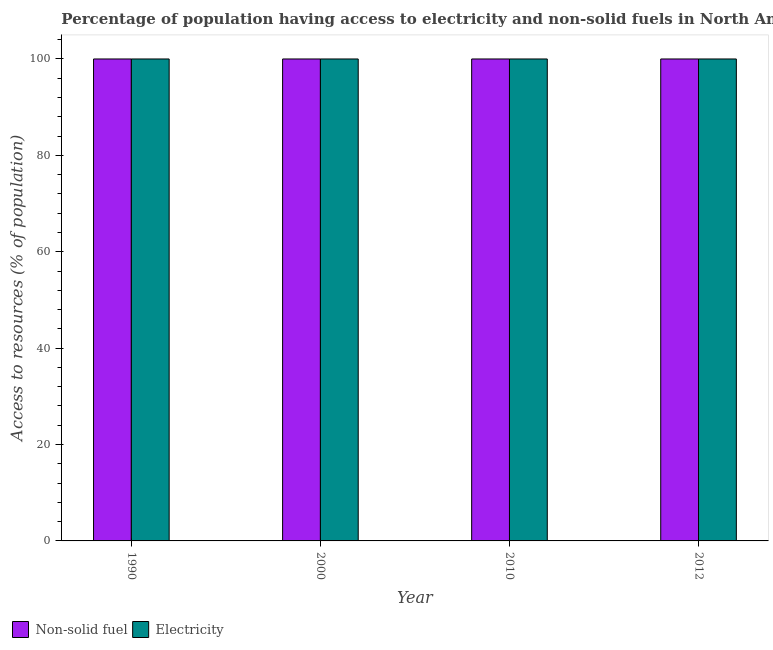How many different coloured bars are there?
Ensure brevity in your answer.  2. What is the percentage of population having access to non-solid fuel in 1990?
Keep it short and to the point. 100. Across all years, what is the maximum percentage of population having access to electricity?
Make the answer very short. 100. Across all years, what is the minimum percentage of population having access to non-solid fuel?
Your response must be concise. 100. In which year was the percentage of population having access to electricity minimum?
Provide a short and direct response. 1990. What is the total percentage of population having access to electricity in the graph?
Ensure brevity in your answer.  400. What is the difference between the percentage of population having access to non-solid fuel in 2010 and that in 2012?
Offer a terse response. 0. In the year 2012, what is the difference between the percentage of population having access to electricity and percentage of population having access to non-solid fuel?
Make the answer very short. 0. In how many years, is the percentage of population having access to electricity greater than 84 %?
Keep it short and to the point. 4. What is the ratio of the percentage of population having access to electricity in 2000 to that in 2010?
Give a very brief answer. 1. Is the percentage of population having access to electricity in 2000 less than that in 2010?
Your response must be concise. No. What is the difference between the highest and the second highest percentage of population having access to non-solid fuel?
Your response must be concise. 0. What is the difference between the highest and the lowest percentage of population having access to electricity?
Your response must be concise. 0. Is the sum of the percentage of population having access to electricity in 2010 and 2012 greater than the maximum percentage of population having access to non-solid fuel across all years?
Give a very brief answer. Yes. What does the 2nd bar from the left in 2000 represents?
Make the answer very short. Electricity. What does the 2nd bar from the right in 1990 represents?
Offer a terse response. Non-solid fuel. How many years are there in the graph?
Your answer should be very brief. 4. What is the difference between two consecutive major ticks on the Y-axis?
Make the answer very short. 20. Are the values on the major ticks of Y-axis written in scientific E-notation?
Your answer should be compact. No. Does the graph contain any zero values?
Ensure brevity in your answer.  No. Does the graph contain grids?
Provide a short and direct response. No. Where does the legend appear in the graph?
Ensure brevity in your answer.  Bottom left. How many legend labels are there?
Offer a terse response. 2. What is the title of the graph?
Provide a short and direct response. Percentage of population having access to electricity and non-solid fuels in North America. Does "Total Population" appear as one of the legend labels in the graph?
Your response must be concise. No. What is the label or title of the X-axis?
Offer a very short reply. Year. What is the label or title of the Y-axis?
Make the answer very short. Access to resources (% of population). What is the Access to resources (% of population) in Non-solid fuel in 2010?
Make the answer very short. 100. What is the Access to resources (% of population) in Electricity in 2010?
Give a very brief answer. 100. Across all years, what is the minimum Access to resources (% of population) in Non-solid fuel?
Ensure brevity in your answer.  100. Across all years, what is the minimum Access to resources (% of population) of Electricity?
Your answer should be very brief. 100. What is the difference between the Access to resources (% of population) of Electricity in 1990 and that in 2000?
Give a very brief answer. 0. What is the difference between the Access to resources (% of population) of Non-solid fuel in 1990 and that in 2010?
Your response must be concise. 0. What is the difference between the Access to resources (% of population) of Non-solid fuel in 1990 and that in 2012?
Offer a very short reply. 0. What is the difference between the Access to resources (% of population) in Non-solid fuel in 2000 and that in 2012?
Ensure brevity in your answer.  0. What is the difference between the Access to resources (% of population) in Non-solid fuel in 2010 and that in 2012?
Provide a succinct answer. 0. What is the difference between the Access to resources (% of population) in Non-solid fuel in 2000 and the Access to resources (% of population) in Electricity in 2010?
Keep it short and to the point. 0. What is the difference between the Access to resources (% of population) in Non-solid fuel in 2010 and the Access to resources (% of population) in Electricity in 2012?
Your answer should be very brief. 0. In the year 1990, what is the difference between the Access to resources (% of population) of Non-solid fuel and Access to resources (% of population) of Electricity?
Your response must be concise. 0. In the year 2000, what is the difference between the Access to resources (% of population) in Non-solid fuel and Access to resources (% of population) in Electricity?
Your response must be concise. 0. In the year 2010, what is the difference between the Access to resources (% of population) in Non-solid fuel and Access to resources (% of population) in Electricity?
Provide a succinct answer. 0. In the year 2012, what is the difference between the Access to resources (% of population) of Non-solid fuel and Access to resources (% of population) of Electricity?
Your answer should be compact. 0. What is the ratio of the Access to resources (% of population) in Electricity in 1990 to that in 2000?
Your response must be concise. 1. What is the ratio of the Access to resources (% of population) in Non-solid fuel in 1990 to that in 2012?
Provide a short and direct response. 1. What is the ratio of the Access to resources (% of population) in Non-solid fuel in 2000 to that in 2010?
Make the answer very short. 1. What is the ratio of the Access to resources (% of population) of Non-solid fuel in 2010 to that in 2012?
Offer a very short reply. 1. What is the difference between the highest and the second highest Access to resources (% of population) of Electricity?
Your answer should be very brief. 0. 